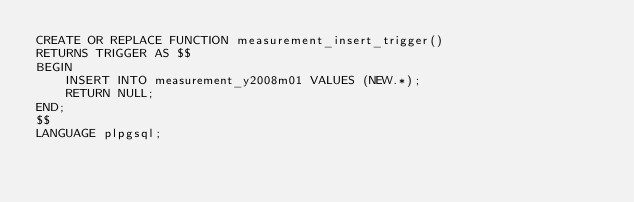<code> <loc_0><loc_0><loc_500><loc_500><_SQL_>CREATE OR REPLACE FUNCTION measurement_insert_trigger()
RETURNS TRIGGER AS $$
BEGIN
    INSERT INTO measurement_y2008m01 VALUES (NEW.*);
    RETURN NULL;
END;
$$
LANGUAGE plpgsql;
</code> 